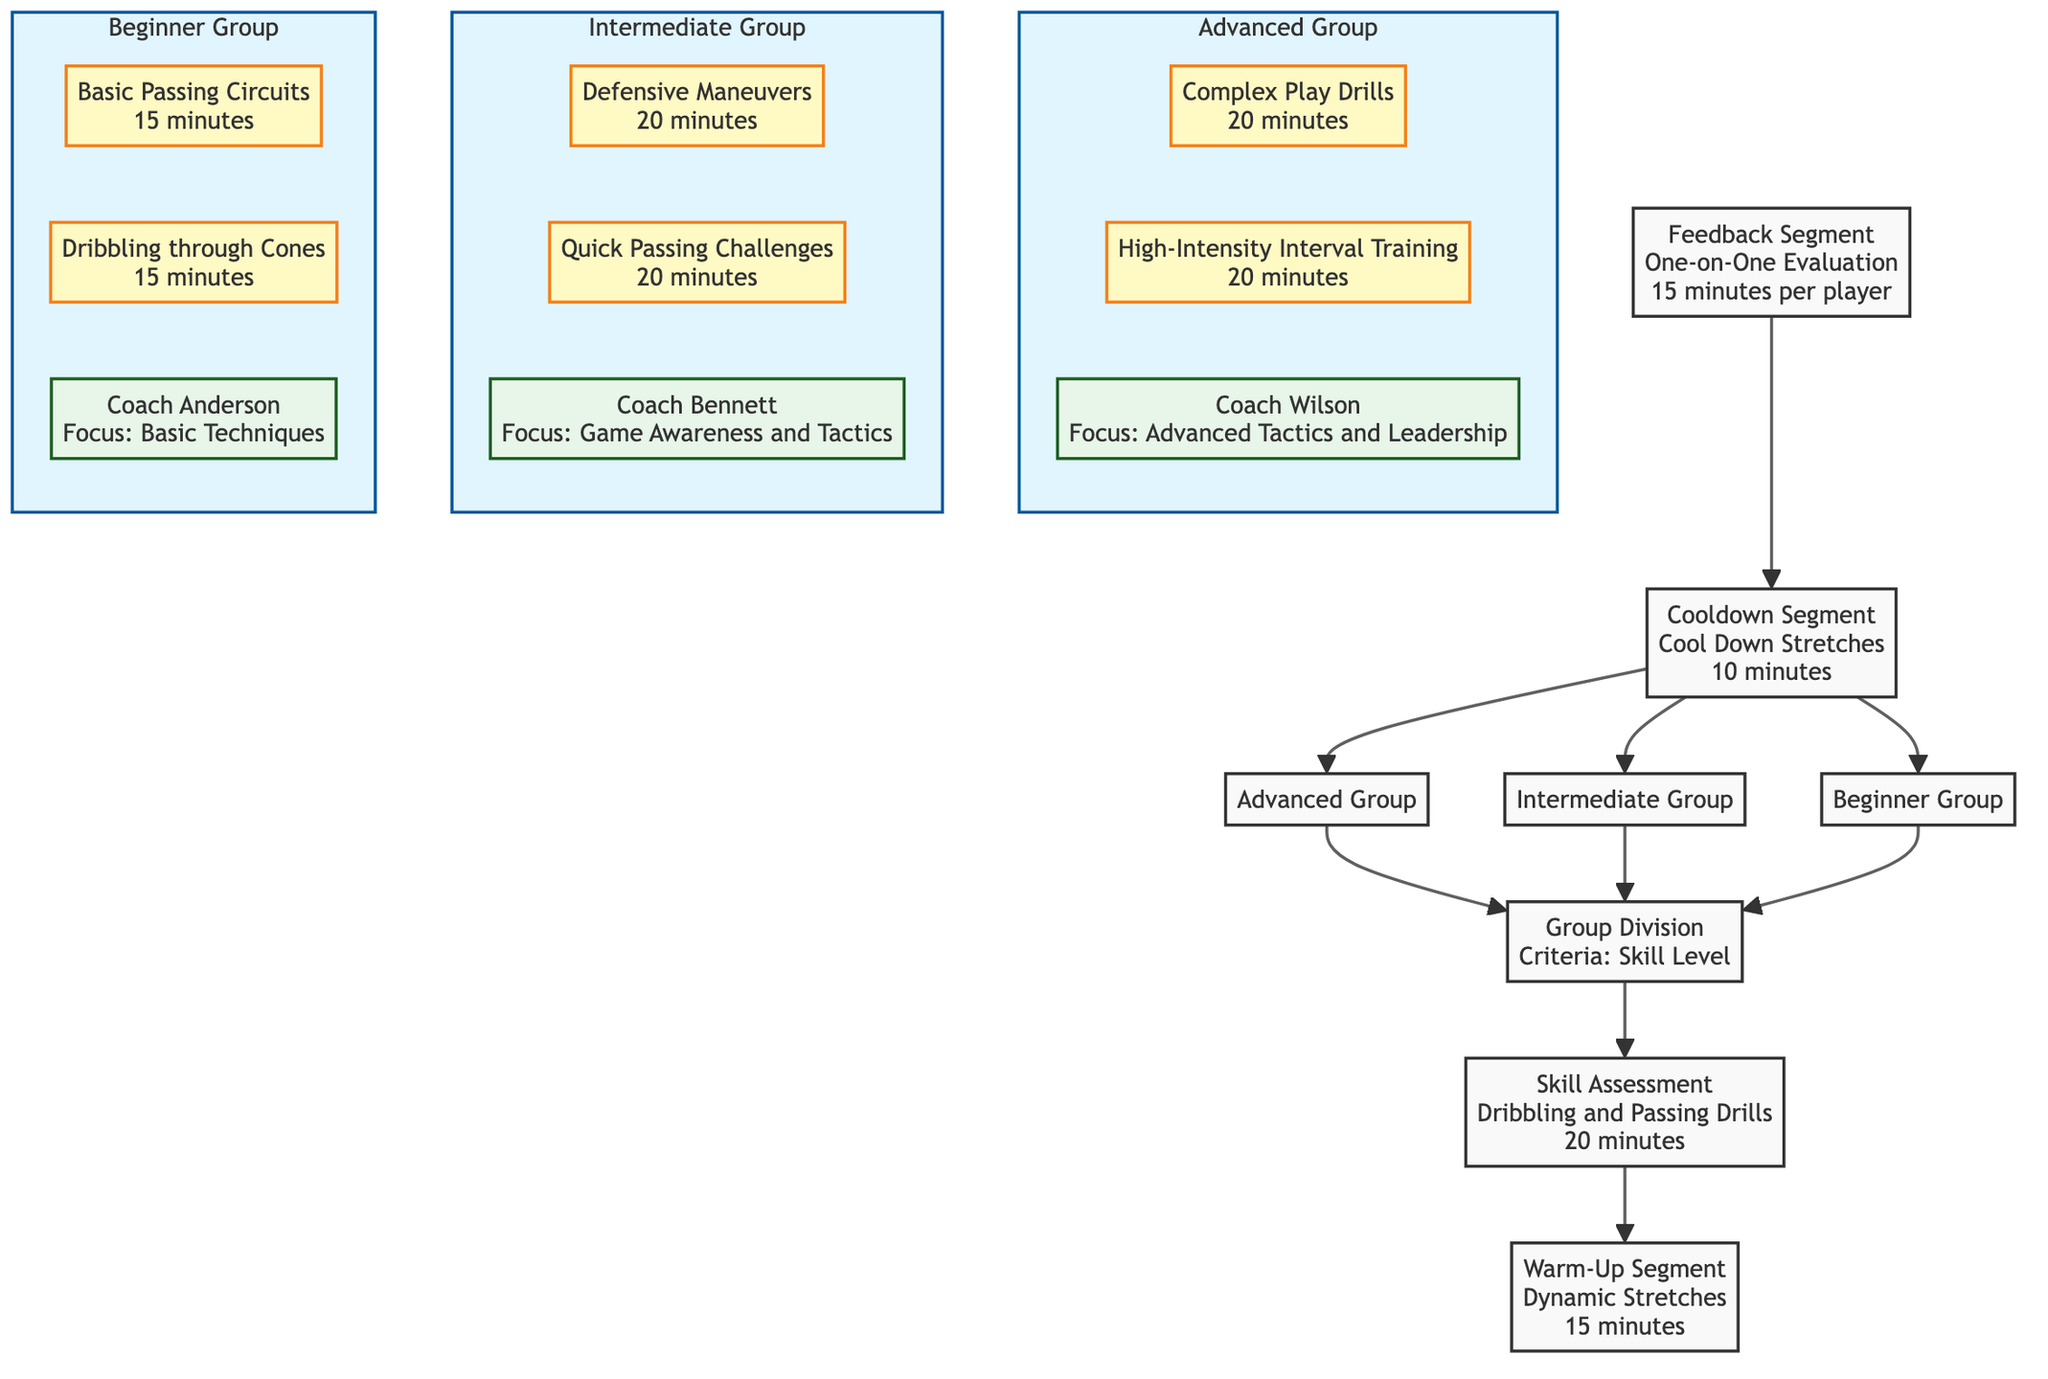What is the duration of the Warm-Up Segment? The Warm-Up Segment node specifies "Dynamic Stretches" with a duration of "15 minutes". Thus, the answer is directly found in the node itself.
Answer: 15 minutes What is the main objective of the Skill Assessment? The Skill Assessment node clearly states its objective is "Evaluate player's current skill levels". This can be derived directly from the information provided in that node.
Answer: Evaluate player's current skill levels How many groups are divided based on skill level? The Group Division node lists three groups: "Beginner", "Intermediate", and "Advanced". Counting these groups gives a total of three, which is the answer sought.
Answer: 3 What drills are included in the Beginner Group? The Beginner Group node contains two drills: "Basic Passing Circuits" and "Dribbling through Cones". Listing these drills confirms the answer.
Answer: Basic Passing Circuits, Dribbling through Cones Which mentor focuses on Advanced Tactics and Leadership? The Advanced Group node identifies that Coach Wilson is the mentor for this group, whose focus area is "Advanced Tactics and Leadership". This information is taken from the specific details about the mentor in that group.
Answer: Coach Wilson What is the last segment in the training session flow? By following the flow from bottom to up, the last segment that precedes the Cooldown Segment is the Feedback Segment. The positioning of the nodes in the diagram illustrates the order clearly.
Answer: Feedback Segment What is the duration of feedback for each player? The Feedback Segment specifies the duration is "15 minutes per player". This information can easily be extracted from the node description.
Answer: 15 minutes per player What skills are emphasized in the Intermediate Group drills? The Intermediate Group focuses on drills for "Defensive Maneuvers" and "Quick Passing Challenges". By examining the Intermediate Group node, we can ascertain the skills targeted through these drills.
Answer: Defensive Maneuvers, Quick Passing Challenges How does the flow start in the diagram? The flowchart begins with the Warm-Up Segment, which is the first node encountered at the bottom of the diagram. This information is derived by tracing the connections upwards to see the initial action.
Answer: Warm-Up Segment 